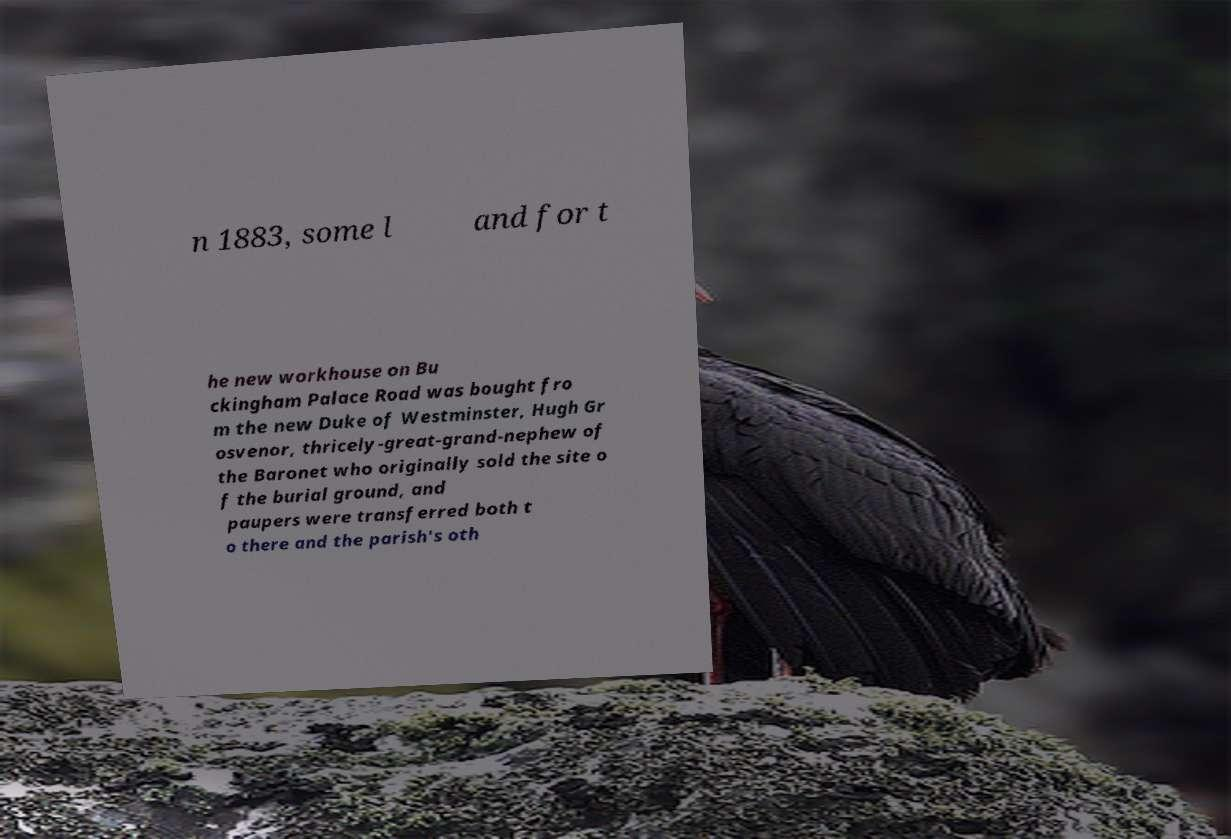What messages or text are displayed in this image? I need them in a readable, typed format. n 1883, some l and for t he new workhouse on Bu ckingham Palace Road was bought fro m the new Duke of Westminster, Hugh Gr osvenor, thricely-great-grand-nephew of the Baronet who originally sold the site o f the burial ground, and paupers were transferred both t o there and the parish's oth 